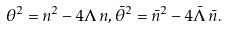<formula> <loc_0><loc_0><loc_500><loc_500>\theta ^ { 2 } = n ^ { 2 } - 4 \Lambda \, n , \bar { \theta } ^ { 2 } = \bar { n } ^ { 2 } - 4 \bar { \Lambda } \, \bar { n } .</formula> 